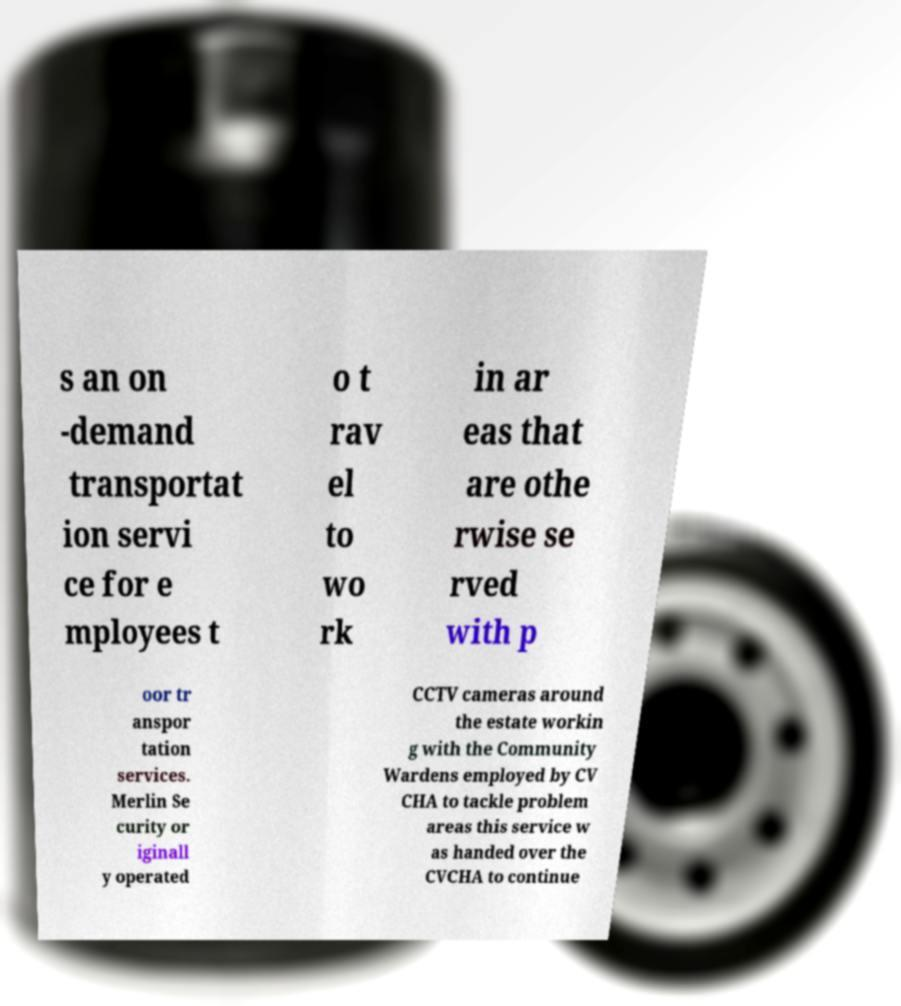Please identify and transcribe the text found in this image. s an on -demand transportat ion servi ce for e mployees t o t rav el to wo rk in ar eas that are othe rwise se rved with p oor tr anspor tation services. Merlin Se curity or iginall y operated CCTV cameras around the estate workin g with the Community Wardens employed by CV CHA to tackle problem areas this service w as handed over the CVCHA to continue 